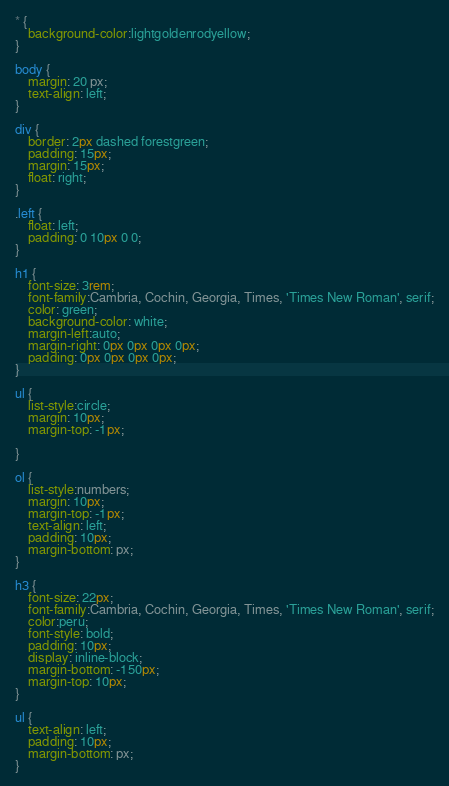Convert code to text. <code><loc_0><loc_0><loc_500><loc_500><_CSS_>* {
    background-color:lightgoldenrodyellow; 
}

body {
    margin: 20 px;
    text-align: left;
}

div {
    border: 2px dashed forestgreen;
    padding: 15px;
    margin: 15px;
    float: right;
}

.left {
    float: left;
    padding: 0 10px 0 0;
}

h1 {
    font-size: 3rem;
    font-family:Cambria, Cochin, Georgia, Times, 'Times New Roman', serif;
    color: green;
    background-color: white;
    margin-left:auto;
    margin-right: 0px 0px 0px 0px;
    padding: 0px 0px 0px 0px;
}

ul {
    list-style:circle;
    margin: 10px;
    margin-top: -1px;
    
}

ol {
    list-style:numbers;
    margin: 10px;
    margin-top: -1px;
    text-align: left;
    padding: 10px;
    margin-bottom: px;
}

h3 {
    font-size: 22px;
    font-family:Cambria, Cochin, Georgia, Times, 'Times New Roman', serif;
    color:peru;
    font-style: bold;
    padding: 10px; 
    display: inline-block;
    margin-bottom: -150px;
    margin-top: 10px;
}

ul {
    text-align: left;
    padding: 10px;
    margin-bottom: px;
}
</code> 